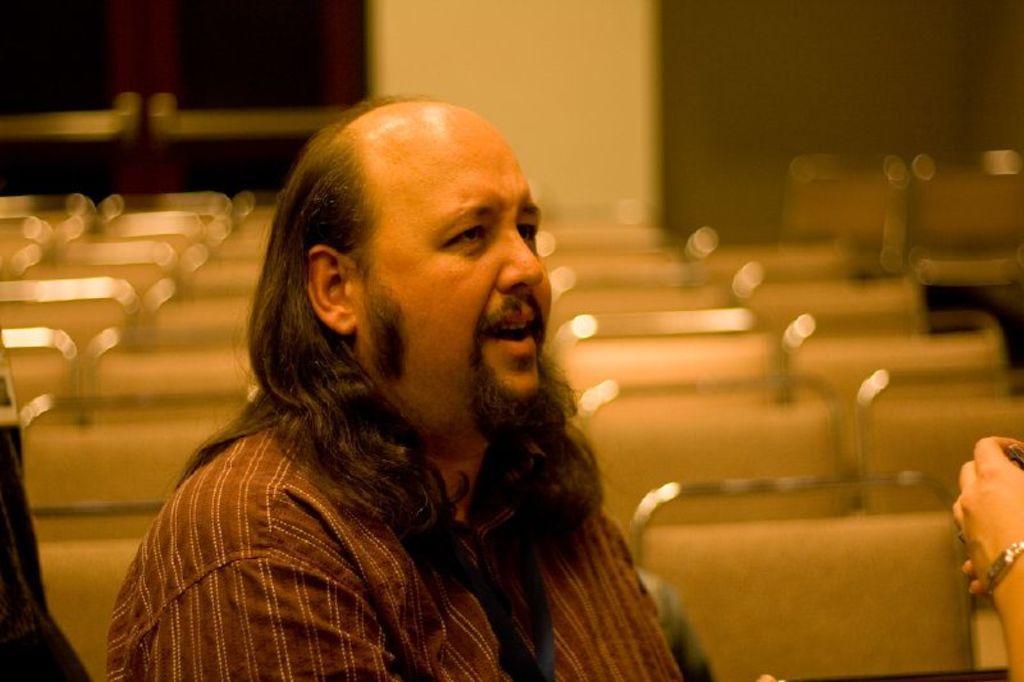Can you describe this image briefly? Background portion of the picture is blurred. In this picture we can see the chairs, person, door and the wall. On the right side of the picture we can see a person's hand. 